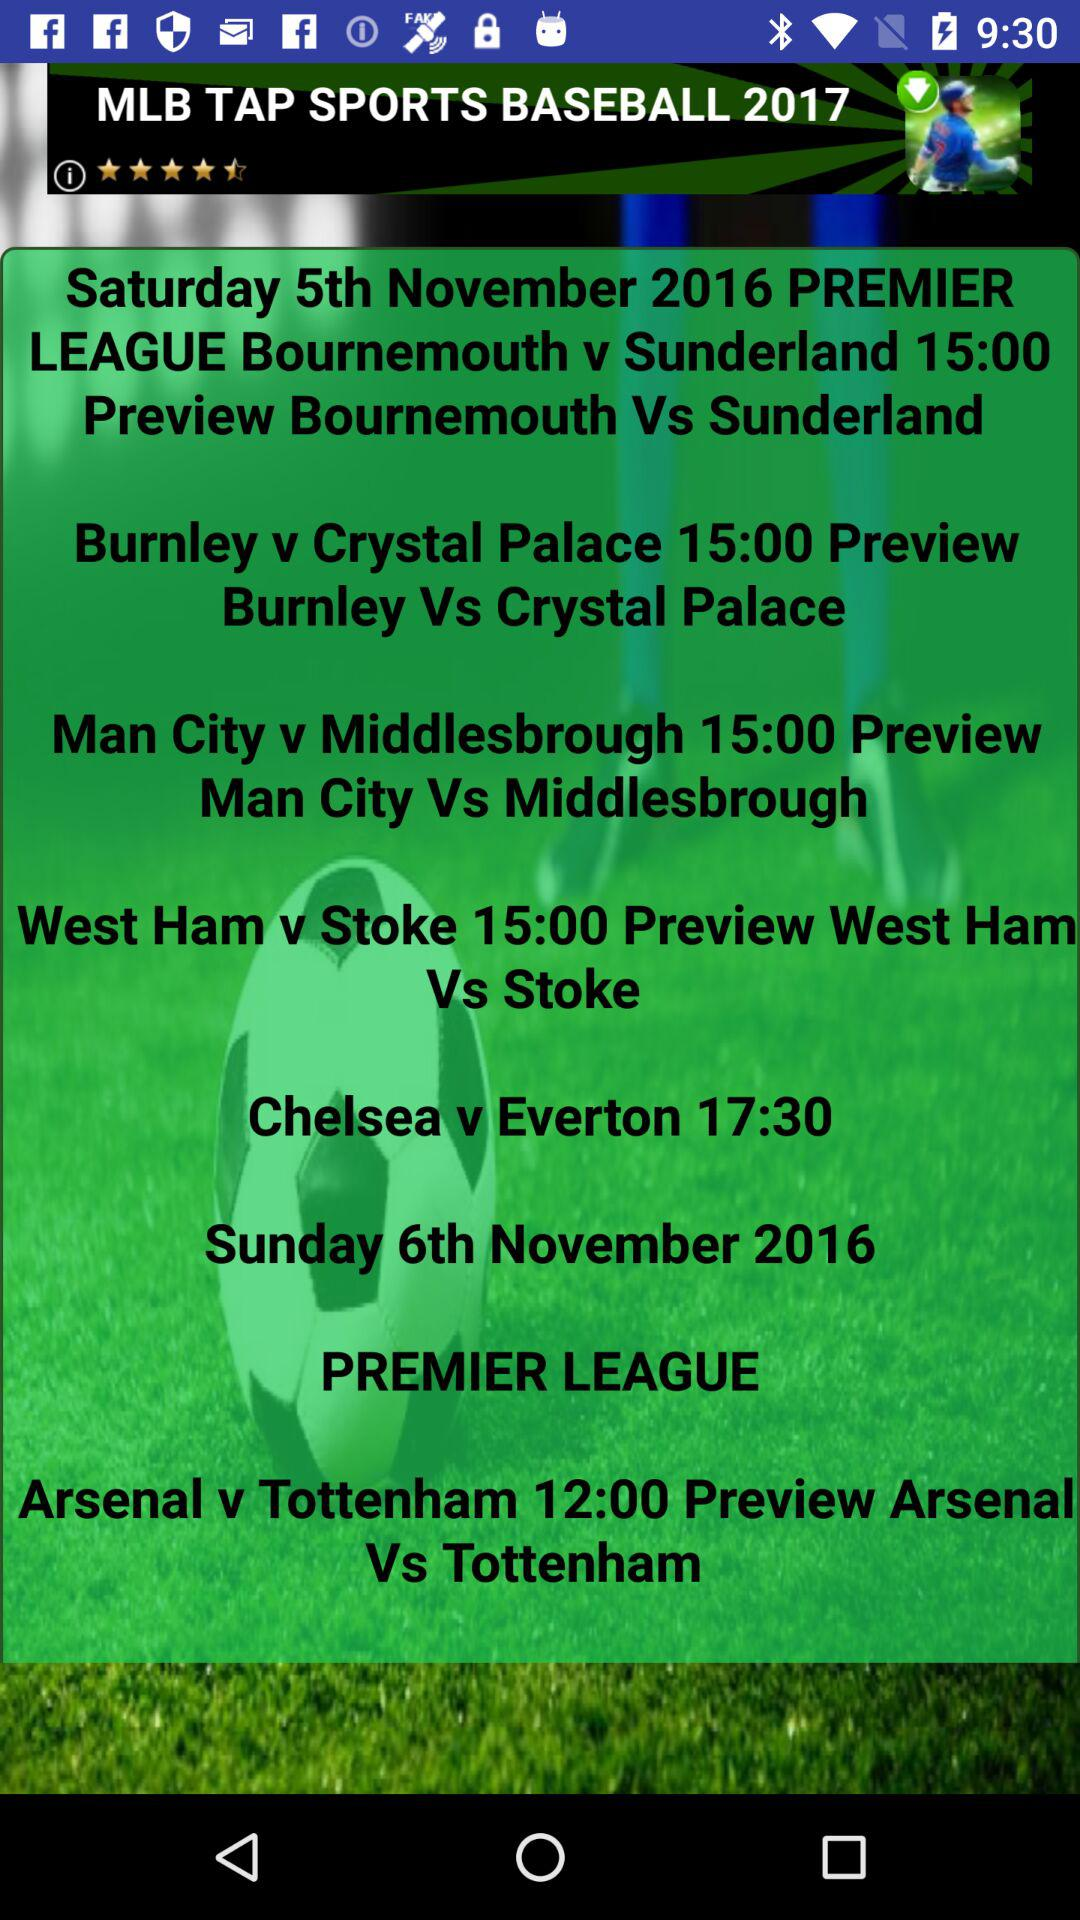What is the timing of Man City vs Middlesbrough? The timing of Man City vs Middlesbrough is 15:00. 